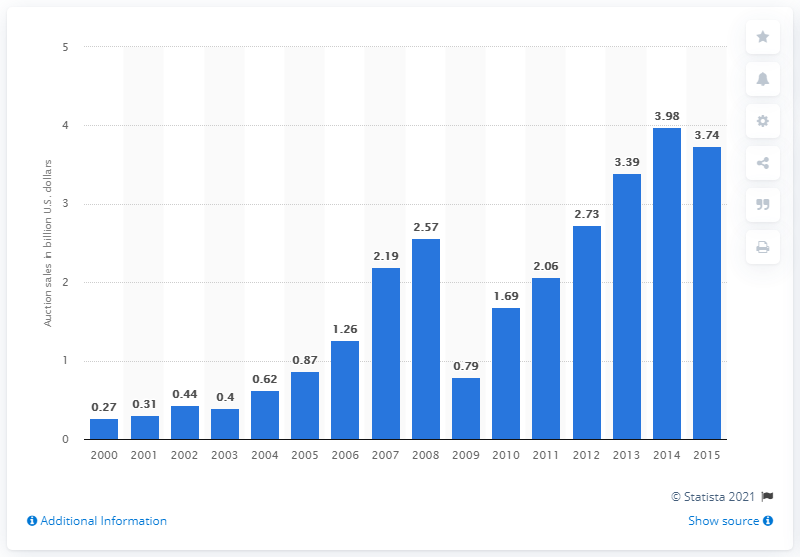Identify some key points in this picture. The auction sales of post-war and contemporary art reached 3.39 billion dollars in 2013. 